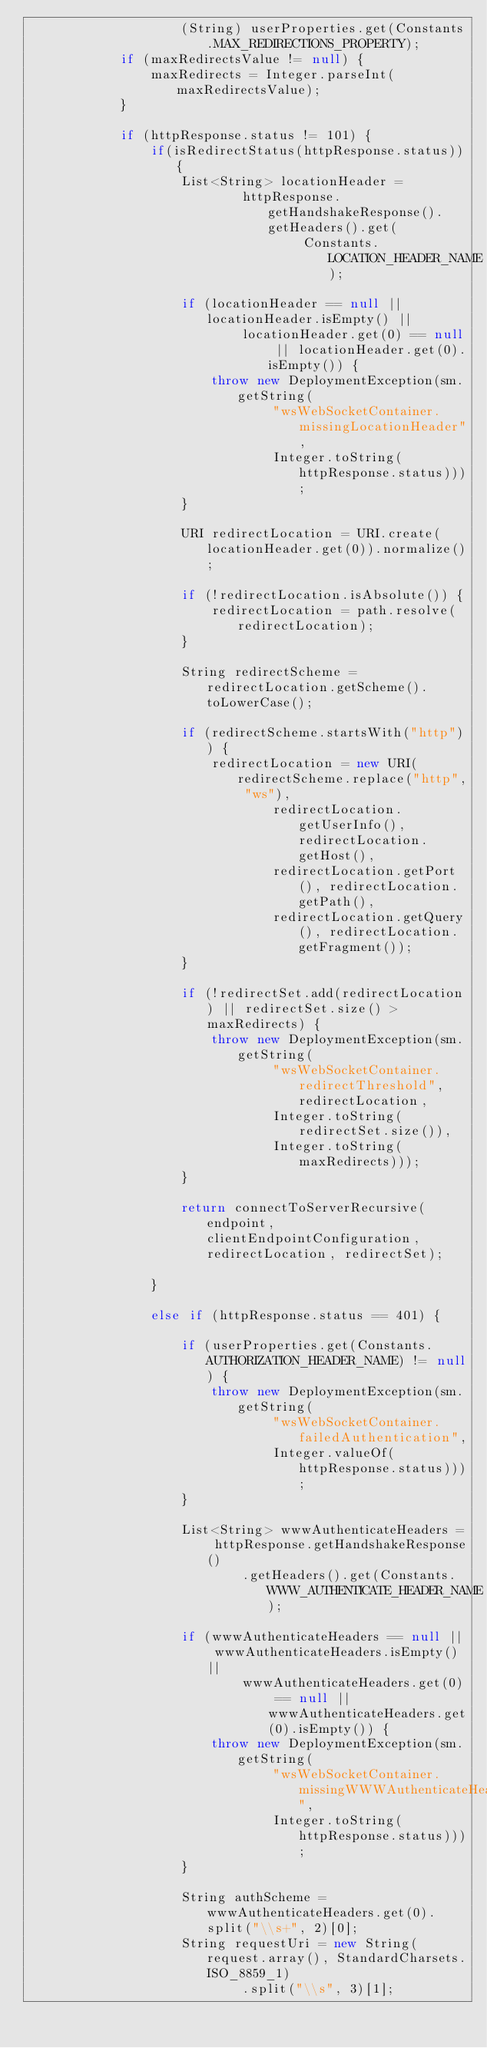Convert code to text. <code><loc_0><loc_0><loc_500><loc_500><_Java_>                    (String) userProperties.get(Constants.MAX_REDIRECTIONS_PROPERTY);
            if (maxRedirectsValue != null) {
                maxRedirects = Integer.parseInt(maxRedirectsValue);
            }

            if (httpResponse.status != 101) {
                if(isRedirectStatus(httpResponse.status)){
                    List<String> locationHeader =
                            httpResponse.getHandshakeResponse().getHeaders().get(
                                    Constants.LOCATION_HEADER_NAME);

                    if (locationHeader == null || locationHeader.isEmpty() ||
                            locationHeader.get(0) == null || locationHeader.get(0).isEmpty()) {
                        throw new DeploymentException(sm.getString(
                                "wsWebSocketContainer.missingLocationHeader",
                                Integer.toString(httpResponse.status)));
                    }

                    URI redirectLocation = URI.create(locationHeader.get(0)).normalize();

                    if (!redirectLocation.isAbsolute()) {
                        redirectLocation = path.resolve(redirectLocation);
                    }

                    String redirectScheme = redirectLocation.getScheme().toLowerCase();

                    if (redirectScheme.startsWith("http")) {
                        redirectLocation = new URI(redirectScheme.replace("http", "ws"),
                                redirectLocation.getUserInfo(), redirectLocation.getHost(),
                                redirectLocation.getPort(), redirectLocation.getPath(),
                                redirectLocation.getQuery(), redirectLocation.getFragment());
                    }

                    if (!redirectSet.add(redirectLocation) || redirectSet.size() > maxRedirects) {
                        throw new DeploymentException(sm.getString(
                                "wsWebSocketContainer.redirectThreshold", redirectLocation,
                                Integer.toString(redirectSet.size()),
                                Integer.toString(maxRedirects)));
                    }

                    return connectToServerRecursive(endpoint, clientEndpointConfiguration, redirectLocation, redirectSet);

                }

                else if (httpResponse.status == 401) {

                    if (userProperties.get(Constants.AUTHORIZATION_HEADER_NAME) != null) {
                        throw new DeploymentException(sm.getString(
                                "wsWebSocketContainer.failedAuthentication",
                                Integer.valueOf(httpResponse.status)));
                    }

                    List<String> wwwAuthenticateHeaders = httpResponse.getHandshakeResponse()
                            .getHeaders().get(Constants.WWW_AUTHENTICATE_HEADER_NAME);

                    if (wwwAuthenticateHeaders == null || wwwAuthenticateHeaders.isEmpty() ||
                            wwwAuthenticateHeaders.get(0) == null || wwwAuthenticateHeaders.get(0).isEmpty()) {
                        throw new DeploymentException(sm.getString(
                                "wsWebSocketContainer.missingWWWAuthenticateHeader",
                                Integer.toString(httpResponse.status)));
                    }

                    String authScheme = wwwAuthenticateHeaders.get(0).split("\\s+", 2)[0];
                    String requestUri = new String(request.array(), StandardCharsets.ISO_8859_1)
                            .split("\\s", 3)[1];</code> 